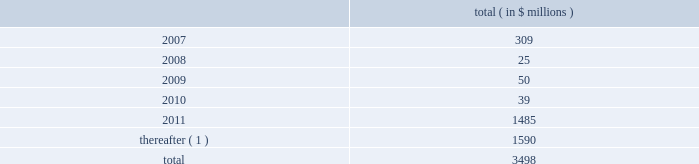2022 designate subsidiaries as unrestricted subsidiaries ; and 2022 sell certain assets or merge with or into other companies .
Subject to certain exceptions , the indentures governing the senior subordinated notes and the senior discount notes permit the issuers of the notes and their restricted subsidiaries to incur additional indebtedness , including secured indebtedness .
In addition , the senior credit facilities require bcp crystal to maintain the following financial covenants : a maximum total leverage ratio , a maximum bank debt leverage ratio , a minimum interest coverage ratio and maximum capital expenditures limitation .
The maximum consolidated net bank debt to adjusted ebitda ratio , as defined , previously required under the senior credit facilities , was eliminated when the company amended the facilities in january 2005 .
As of december 31 , 2006 , the company was in compliance with all of the financial covenants related to its debt agreements .
Principal payments scheduled to be made on the company 2019s debt , including short term borrowings , is as follows : ( in $ millions ) .
( 1 ) includes $ 2 million purchase accounting adjustment to assumed debt .
17 .
Benefit obligations pension obligations .
Pension obligations are established for benefits payable in the form of retirement , disability and surviving dependent pensions .
The benefits offered vary according to the legal , fiscal and economic conditions of each country .
The commitments result from participation in defined contribution and defined benefit plans , primarily in the u.s .
Benefits are dependent on years of service and the employee 2019s compensation .
Supplemental retirement benefits provided to certain employees are non-qualified for u.s .
Tax purposes .
Separate trusts have been established for some non-qualified plans .
The company sponsors defined benefit pension plans in north america , europe and asia .
As of december 31 , 2006 , the company 2019s u.s .
Qualified pension plan represented greater than 84% ( 84 % ) and 76% ( 76 % ) of celanese 2019s pension plan assets and liabilities , respectively .
Independent trusts or insurance companies administer the majority of these plans .
Pension costs under the company 2019s retirement plans are actuarially determined .
The company sponsors various defined contribution plans in north america , europe , and asia covering certain employees .
Employees may contribute to these plans and the company will match these contributions in varying amounts .
The company 2019s matching contribution to the defined contribution plans are based on specified percentages of employee contributions and aggregated $ 11 million , $ 12 million , $ 8 million and $ 3 million for the years ended december 31 , 2006 and 2005 , the nine months ended december 31 , 2004 and the three months ended march 31 , 2004 , respectively .
Celanese corporation and subsidiaries notes to consolidated financial statements 2014 ( continued ) .
What is the average of the principal payments scheduled from 2007 to 2011? 
Rationale: the average of the 5 years
Computations: (((3498 - 1590) + 5) / 2)
Answer: 956.5. 2022 designate subsidiaries as unrestricted subsidiaries ; and 2022 sell certain assets or merge with or into other companies .
Subject to certain exceptions , the indentures governing the senior subordinated notes and the senior discount notes permit the issuers of the notes and their restricted subsidiaries to incur additional indebtedness , including secured indebtedness .
In addition , the senior credit facilities require bcp crystal to maintain the following financial covenants : a maximum total leverage ratio , a maximum bank debt leverage ratio , a minimum interest coverage ratio and maximum capital expenditures limitation .
The maximum consolidated net bank debt to adjusted ebitda ratio , as defined , previously required under the senior credit facilities , was eliminated when the company amended the facilities in january 2005 .
As of december 31 , 2006 , the company was in compliance with all of the financial covenants related to its debt agreements .
Principal payments scheduled to be made on the company 2019s debt , including short term borrowings , is as follows : ( in $ millions ) .
( 1 ) includes $ 2 million purchase accounting adjustment to assumed debt .
17 .
Benefit obligations pension obligations .
Pension obligations are established for benefits payable in the form of retirement , disability and surviving dependent pensions .
The benefits offered vary according to the legal , fiscal and economic conditions of each country .
The commitments result from participation in defined contribution and defined benefit plans , primarily in the u.s .
Benefits are dependent on years of service and the employee 2019s compensation .
Supplemental retirement benefits provided to certain employees are non-qualified for u.s .
Tax purposes .
Separate trusts have been established for some non-qualified plans .
The company sponsors defined benefit pension plans in north america , europe and asia .
As of december 31 , 2006 , the company 2019s u.s .
Qualified pension plan represented greater than 84% ( 84 % ) and 76% ( 76 % ) of celanese 2019s pension plan assets and liabilities , respectively .
Independent trusts or insurance companies administer the majority of these plans .
Pension costs under the company 2019s retirement plans are actuarially determined .
The company sponsors various defined contribution plans in north america , europe , and asia covering certain employees .
Employees may contribute to these plans and the company will match these contributions in varying amounts .
The company 2019s matching contribution to the defined contribution plans are based on specified percentages of employee contributions and aggregated $ 11 million , $ 12 million , $ 8 million and $ 3 million for the years ended december 31 , 2006 and 2005 , the nine months ended december 31 , 2004 and the three months ended march 31 , 2004 , respectively .
Celanese corporation and subsidiaries notes to consolidated financial statements 2014 ( continued ) .
What portion of the company's debt is due in the next 12 months? 
Computations: (309 / 3498)
Answer: 0.08834. 